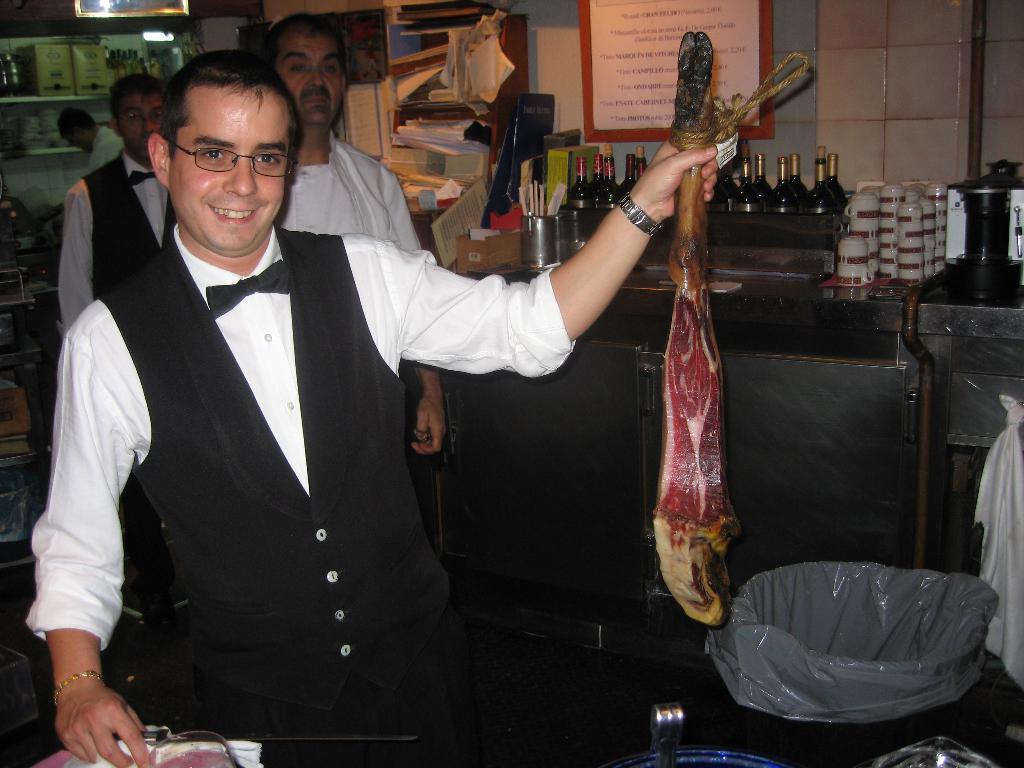How would you summarize this image in a sentence or two? This image is taken indoors. On the left side of the image a man is standing on the floor and he is holding a lamb meat in his hand. At the bottom of the image there is a table with a few things on it. In the background there is a wall with a poster and shelves with a few things on it. In the background two men are standing on the floor and there is a table with many bottles, cups and many things on it. 